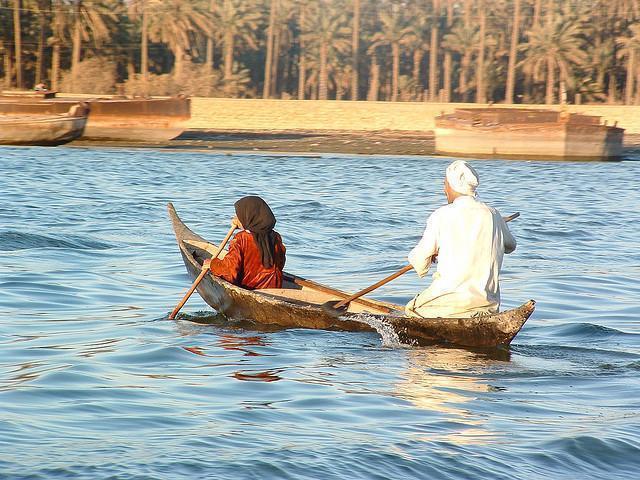What do the people have in their hands?
Answer the question by selecting the correct answer among the 4 following choices.
Options: Eggs, paddles, swords, spears. Paddles. 